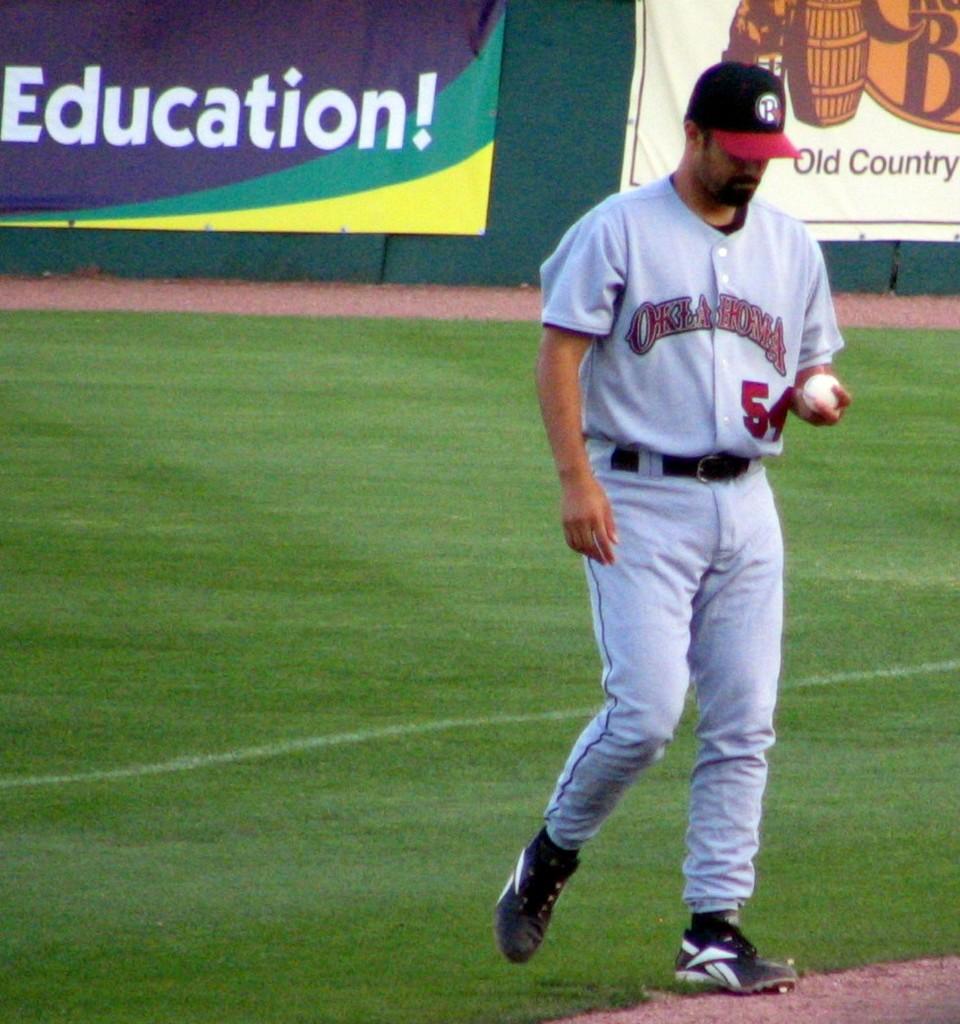What word is printed on the advertisement on the left?
Your answer should be very brief. Education. What team does this player belong to?
Provide a short and direct response. Oklahoma. 